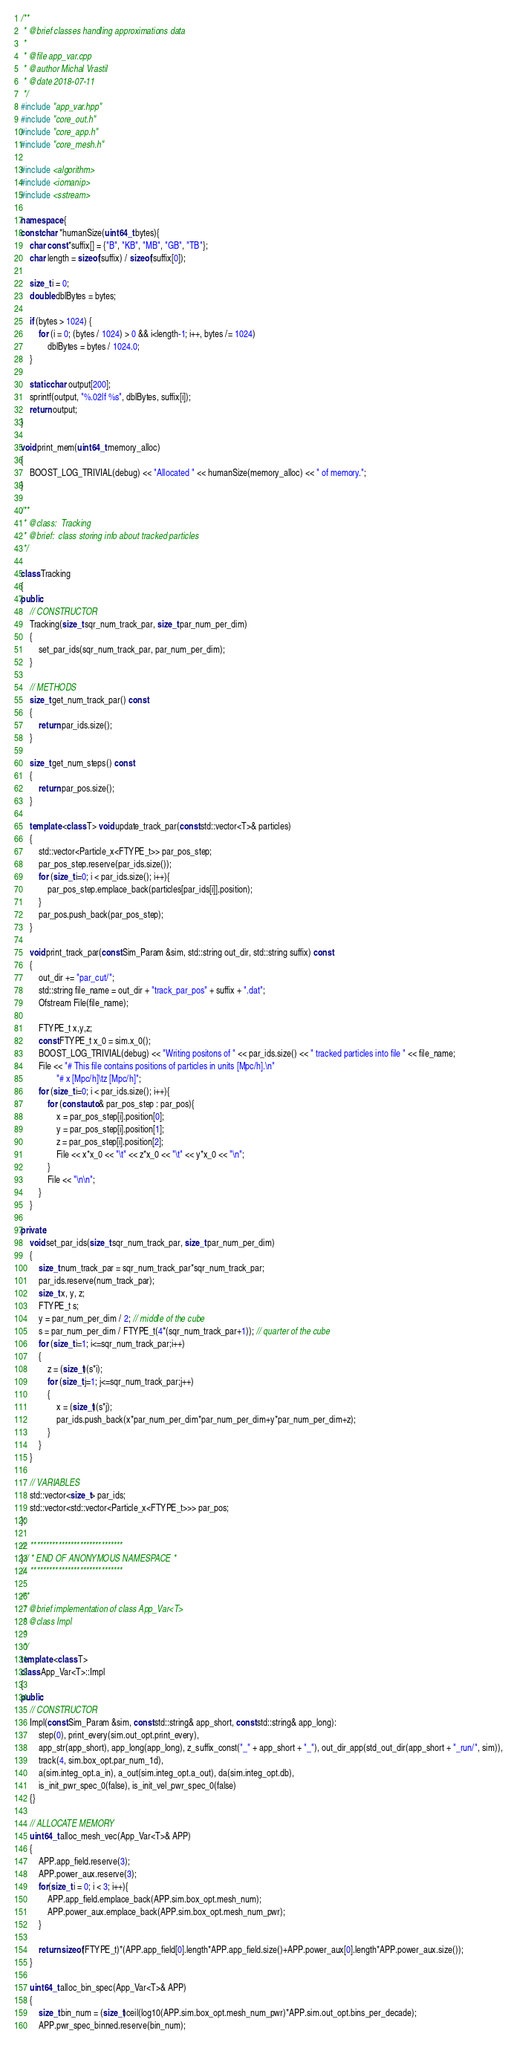Convert code to text. <code><loc_0><loc_0><loc_500><loc_500><_C++_>/**
 * @brief classes handling approximations data
 * 
 * @file app_var.cpp
 * @author Michal Vrastil
 * @date 2018-07-11
 */
#include "app_var.hpp"
#include "core_out.h"
#include "core_app.h"
#include "core_mesh.h"

#include <algorithm>
#include <iomanip>
#include <sstream>

namespace {
const char *humanSize(uint64_t bytes){
	char const *suffix[] = {"B", "KB", "MB", "GB", "TB"};
	char length = sizeof(suffix) / sizeof(suffix[0]);

	size_t i = 0;
	double dblBytes = bytes;

	if (bytes > 1024) {
		for (i = 0; (bytes / 1024) > 0 && i<length-1; i++, bytes /= 1024)
			dblBytes = bytes / 1024.0;
	}

	static char output[200];
	sprintf(output, "%.02lf %s", dblBytes, suffix[i]);
	return output;
}

void print_mem(uint64_t memory_alloc)
{
    BOOST_LOG_TRIVIAL(debug) << "Allocated " << humanSize(memory_alloc) << " of memory.";
}

/**
 * @class:	Tracking
 * @brief:	class storing info about tracked particles
 */

class Tracking
{
public:
	// CONSTRUCTOR
	Tracking(size_t sqr_num_track_par, size_t par_num_per_dim)
    {
        set_par_ids(sqr_num_track_par, par_num_per_dim);
    }

    // METHODS
    size_t get_num_track_par() const
    {
        return par_ids.size();
    }

    size_t get_num_steps() const
    {
        return par_pos.size();
    }

	template <class T> void update_track_par(const std::vector<T>& particles)
    {
        std::vector<Particle_x<FTYPE_t>> par_pos_step;
        par_pos_step.reserve(par_ids.size());
        for (size_t i=0; i < par_ids.size(); i++){
            par_pos_step.emplace_back(particles[par_ids[i]].position);
        }
        par_pos.push_back(par_pos_step);
    }

    void print_track_par(const Sim_Param &sim, std::string out_dir, std::string suffix) const
    {
        out_dir += "par_cut/";
        std::string file_name = out_dir + "track_par_pos" + suffix + ".dat";
        Ofstream File(file_name);

        FTYPE_t x,y,z;
        const FTYPE_t x_0 = sim.x_0();
        BOOST_LOG_TRIVIAL(debug) << "Writing positons of " << par_ids.size() << " tracked particles into file " << file_name;
        File << "# This file contains positions of particles in units [Mpc/h].\n"
                "# x [Mpc/h]\tz [Mpc/h]";
        for (size_t i=0; i < par_ids.size(); i++){
            for (const auto& par_pos_step : par_pos){
                x = par_pos_step[i].position[0];
                y = par_pos_step[i].position[1];
                z = par_pos_step[i].position[2];
                File << x*x_0 << "\t" << z*x_0 << "\t" << y*x_0 << "\n";
            }
            File << "\n\n";
        }
    }

private:
    void set_par_ids(size_t sqr_num_track_par, size_t par_num_per_dim)
    {
        size_t num_track_par = sqr_num_track_par*sqr_num_track_par;
        par_ids.reserve(num_track_par);
        size_t x, y, z;
        FTYPE_t s;
        y = par_num_per_dim / 2; // middle of the cube
        s = par_num_per_dim / FTYPE_t(4*(sqr_num_track_par+1)); // quarter of the cube
        for (size_t i=1; i<=sqr_num_track_par;i++)
        {
            z = (size_t)(s*i);
            for (size_t j=1; j<=sqr_num_track_par;j++)
            {
                x = (size_t)(s*j);
                par_ids.push_back(x*par_num_per_dim*par_num_per_dim+y*par_num_per_dim+z);
            }
        }
    }
	
	// VARIABLES
	std::vector<size_t> par_ids;
	std::vector<std::vector<Particle_x<FTYPE_t>>> par_pos;
};

//  ******************************
}// * END OF ANONYMOUS NAMESPACE *
//  ******************************

/**
 * @brief implementation of class App_Var<T>
 * @class Impl
 * 
 */
template <class T> 
class App_Var<T>::Impl
{
public:
    // CONSTRUCTOR
    Impl(const Sim_Param &sim, const std::string& app_short, const std::string& app_long):
        step(0), print_every(sim.out_opt.print_every),
        app_str(app_short), app_long(app_long), z_suffix_const("_" + app_short + "_"), out_dir_app(std_out_dir(app_short + "_run/", sim)),
        track(4, sim.box_opt.par_num_1d),
        a(sim.integ_opt.a_in), a_out(sim.integ_opt.a_out), da(sim.integ_opt.db),
        is_init_pwr_spec_0(false), is_init_vel_pwr_spec_0(false)
    {}

    // ALLOCATE MEMORY
    uint64_t alloc_mesh_vec(App_Var<T>& APP)
    {
        APP.app_field.reserve(3);
        APP.power_aux.reserve(3);
        for(size_t i = 0; i < 3; i++){
            APP.app_field.emplace_back(APP.sim.box_opt.mesh_num);
            APP.power_aux.emplace_back(APP.sim.box_opt.mesh_num_pwr);
        }

        return sizeof(FTYPE_t)*(APP.app_field[0].length*APP.app_field.size()+APP.power_aux[0].length*APP.power_aux.size());
    }

    uint64_t alloc_bin_spec(App_Var<T>& APP)
    {
        size_t bin_num = (size_t)ceil(log10(APP.sim.box_opt.mesh_num_pwr)*APP.sim.out_opt.bins_per_decade);
        APP.pwr_spec_binned.reserve(bin_num);</code> 